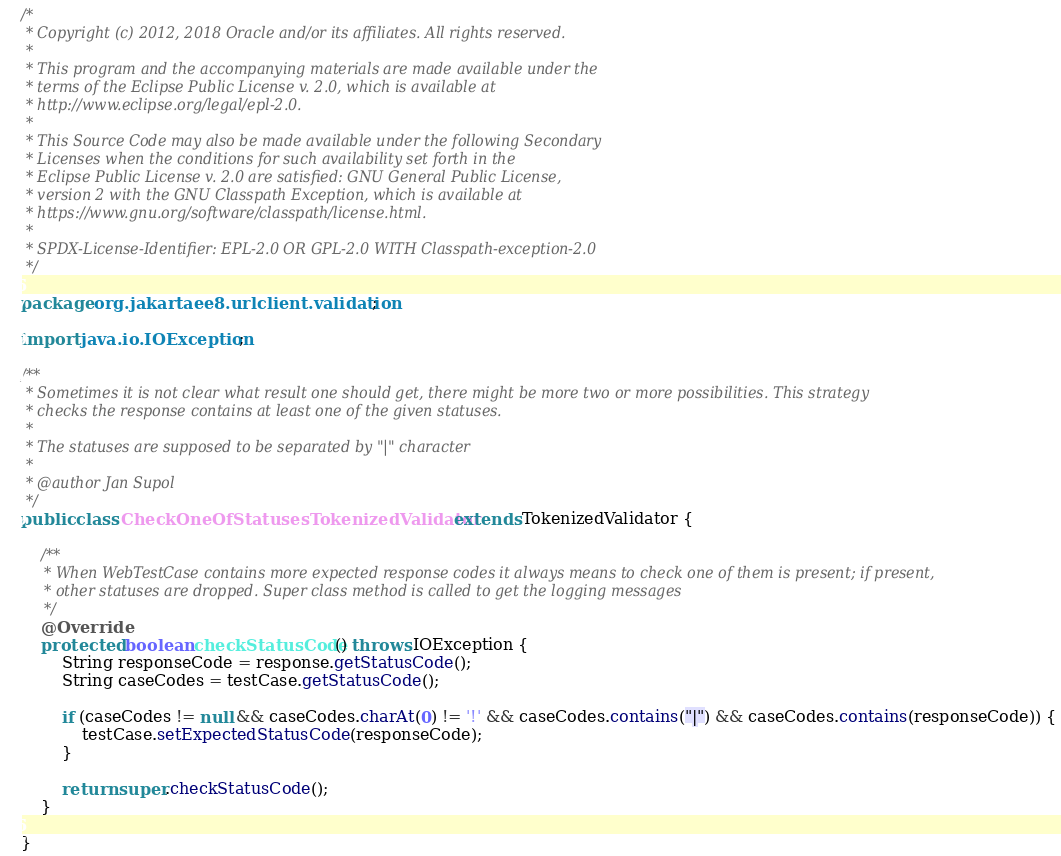Convert code to text. <code><loc_0><loc_0><loc_500><loc_500><_Java_>/*
 * Copyright (c) 2012, 2018 Oracle and/or its affiliates. All rights reserved.
 *
 * This program and the accompanying materials are made available under the
 * terms of the Eclipse Public License v. 2.0, which is available at
 * http://www.eclipse.org/legal/epl-2.0.
 *
 * This Source Code may also be made available under the following Secondary
 * Licenses when the conditions for such availability set forth in the
 * Eclipse Public License v. 2.0 are satisfied: GNU General Public License,
 * version 2 with the GNU Classpath Exception, which is available at
 * https://www.gnu.org/software/classpath/license.html.
 *
 * SPDX-License-Identifier: EPL-2.0 OR GPL-2.0 WITH Classpath-exception-2.0
 */

package org.jakartaee8.urlclient.validation;

import java.io.IOException;

/**
 * Sometimes it is not clear what result one should get, there might be more two or more possibilities. This strategy
 * checks the response contains at least one of the given statuses.
 *
 * The statuses are supposed to be separated by "|" character
 *
 * @author Jan Supol
 */
public class CheckOneOfStatusesTokenizedValidator extends TokenizedValidator {

    /**
     * When WebTestCase contains more expected response codes it always means to check one of them is present; if present,
     * other statuses are dropped. Super class method is called to get the logging messages
     */
    @Override
    protected boolean checkStatusCode() throws IOException {
        String responseCode = response.getStatusCode();
        String caseCodes = testCase.getStatusCode();

        if (caseCodes != null && caseCodes.charAt(0) != '!' && caseCodes.contains("|") && caseCodes.contains(responseCode)) {
            testCase.setExpectedStatusCode(responseCode);
        }

        return super.checkStatusCode();
    }

}
</code> 